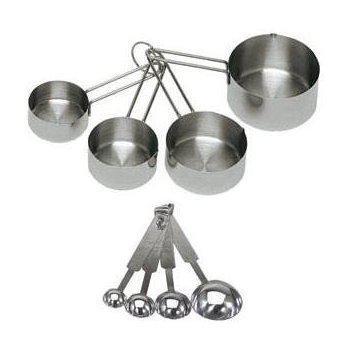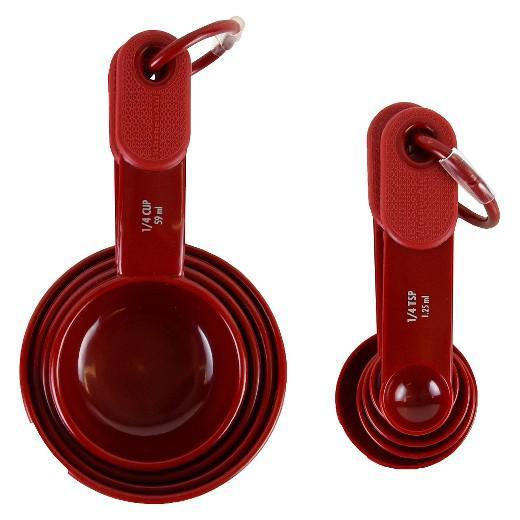The first image is the image on the left, the second image is the image on the right. For the images displayed, is the sentence "One image contains a multicolored measuring set" factually correct? Answer yes or no. No. 